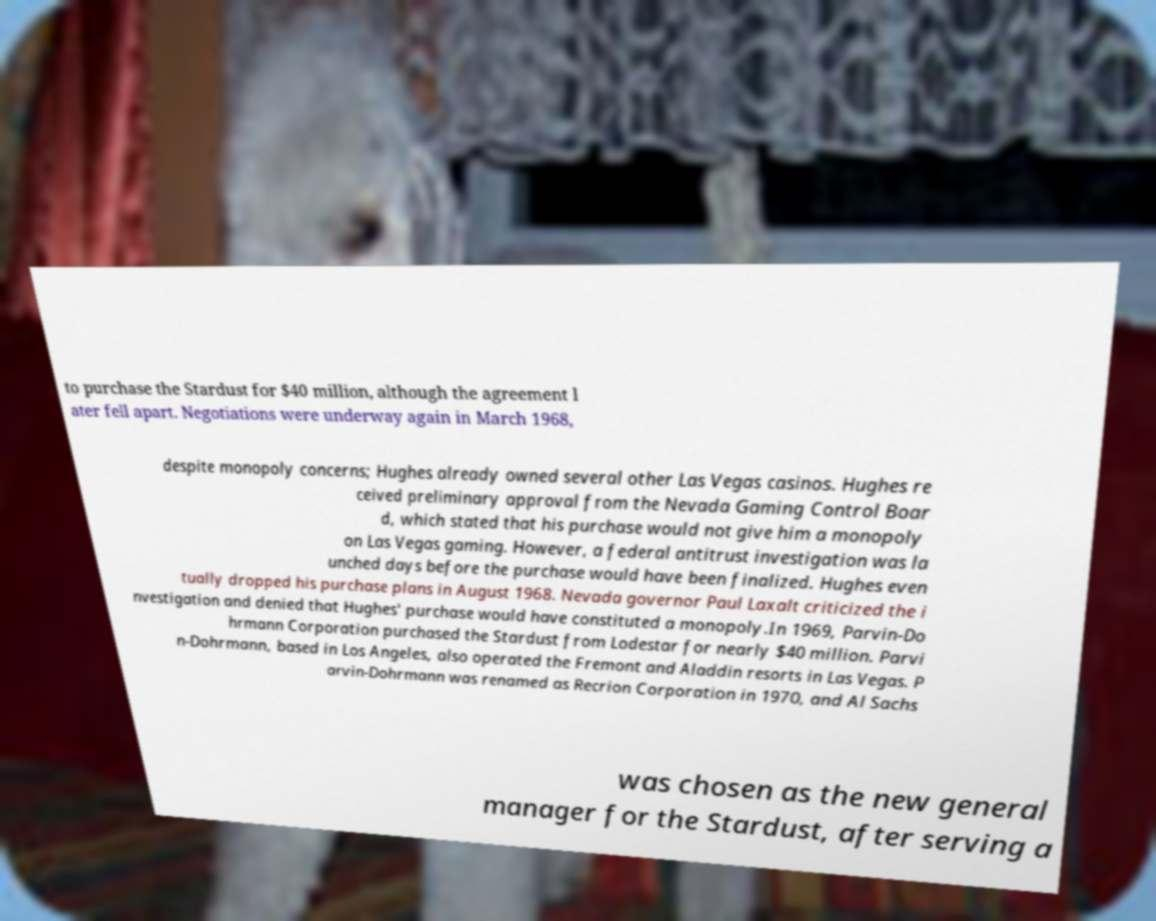Could you extract and type out the text from this image? to purchase the Stardust for $40 million, although the agreement l ater fell apart. Negotiations were underway again in March 1968, despite monopoly concerns; Hughes already owned several other Las Vegas casinos. Hughes re ceived preliminary approval from the Nevada Gaming Control Boar d, which stated that his purchase would not give him a monopoly on Las Vegas gaming. However, a federal antitrust investigation was la unched days before the purchase would have been finalized. Hughes even tually dropped his purchase plans in August 1968. Nevada governor Paul Laxalt criticized the i nvestigation and denied that Hughes' purchase would have constituted a monopoly.In 1969, Parvin-Do hrmann Corporation purchased the Stardust from Lodestar for nearly $40 million. Parvi n-Dohrmann, based in Los Angeles, also operated the Fremont and Aladdin resorts in Las Vegas. P arvin-Dohrmann was renamed as Recrion Corporation in 1970, and Al Sachs was chosen as the new general manager for the Stardust, after serving a 